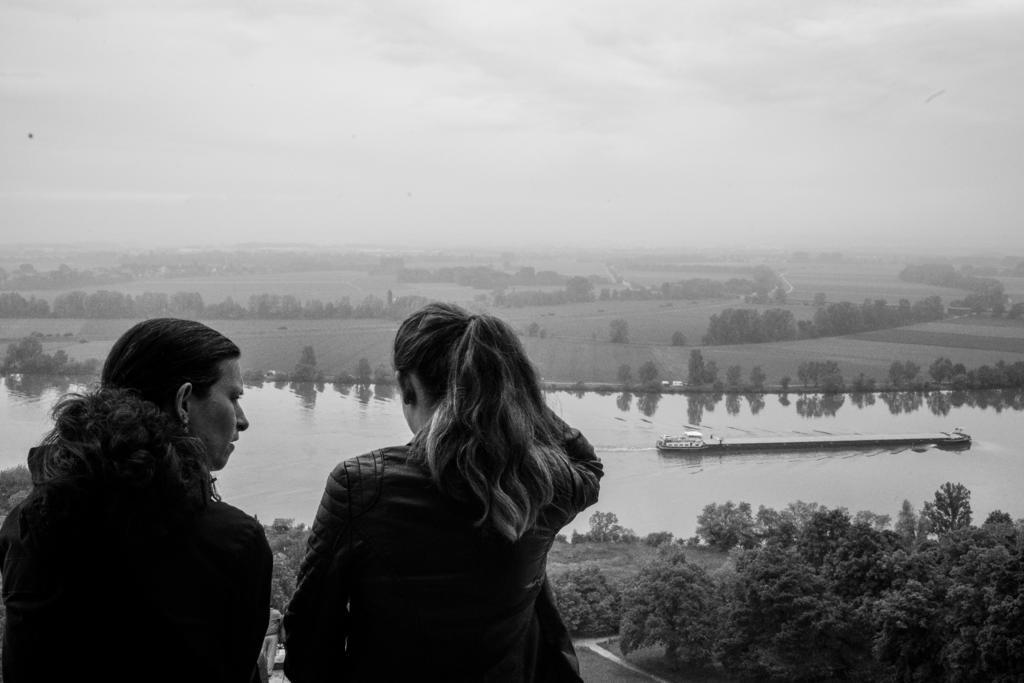Describe this image in one or two sentences. In this picture there are two persons. At the back there are trees and there are vehicles on the road. There is a boat on the water. At the top there are clouds. At the bottom there is water and there is grass. 